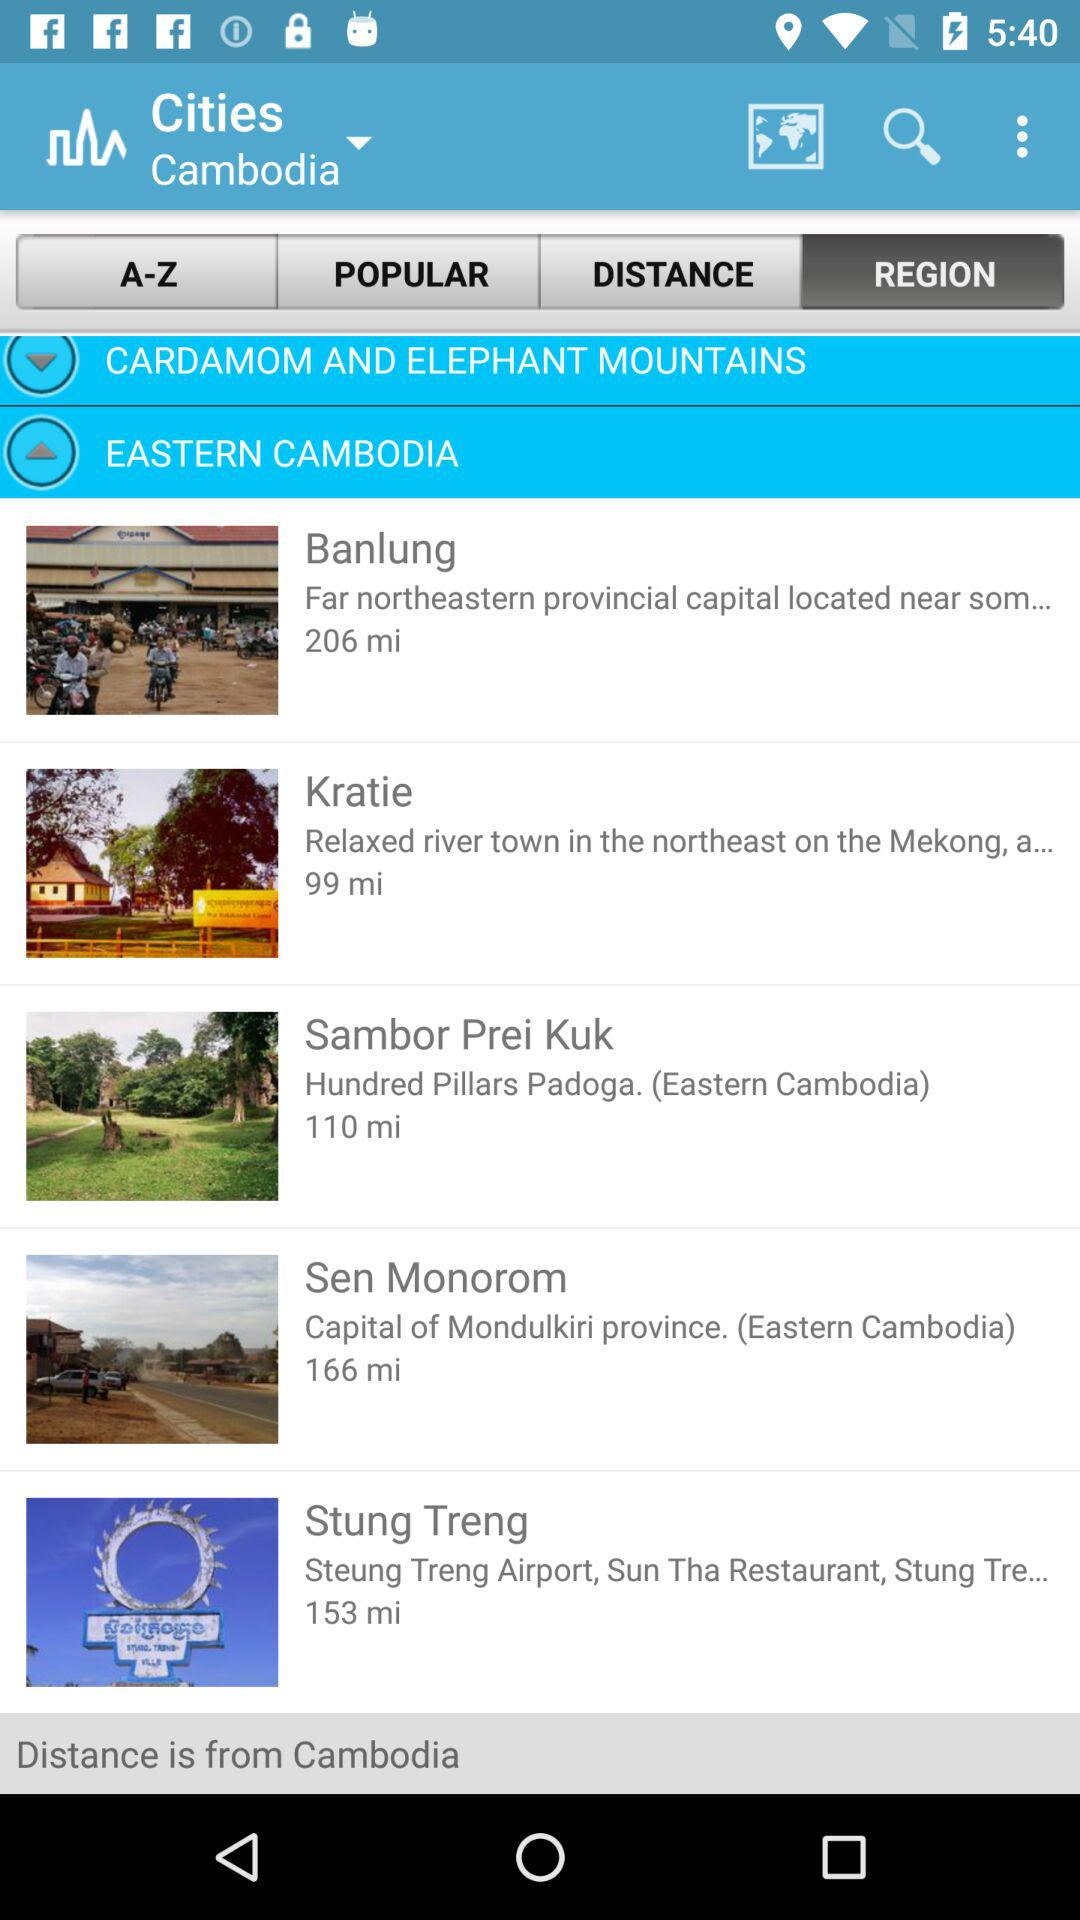What is the selected country? The selected country is Cambodia. 